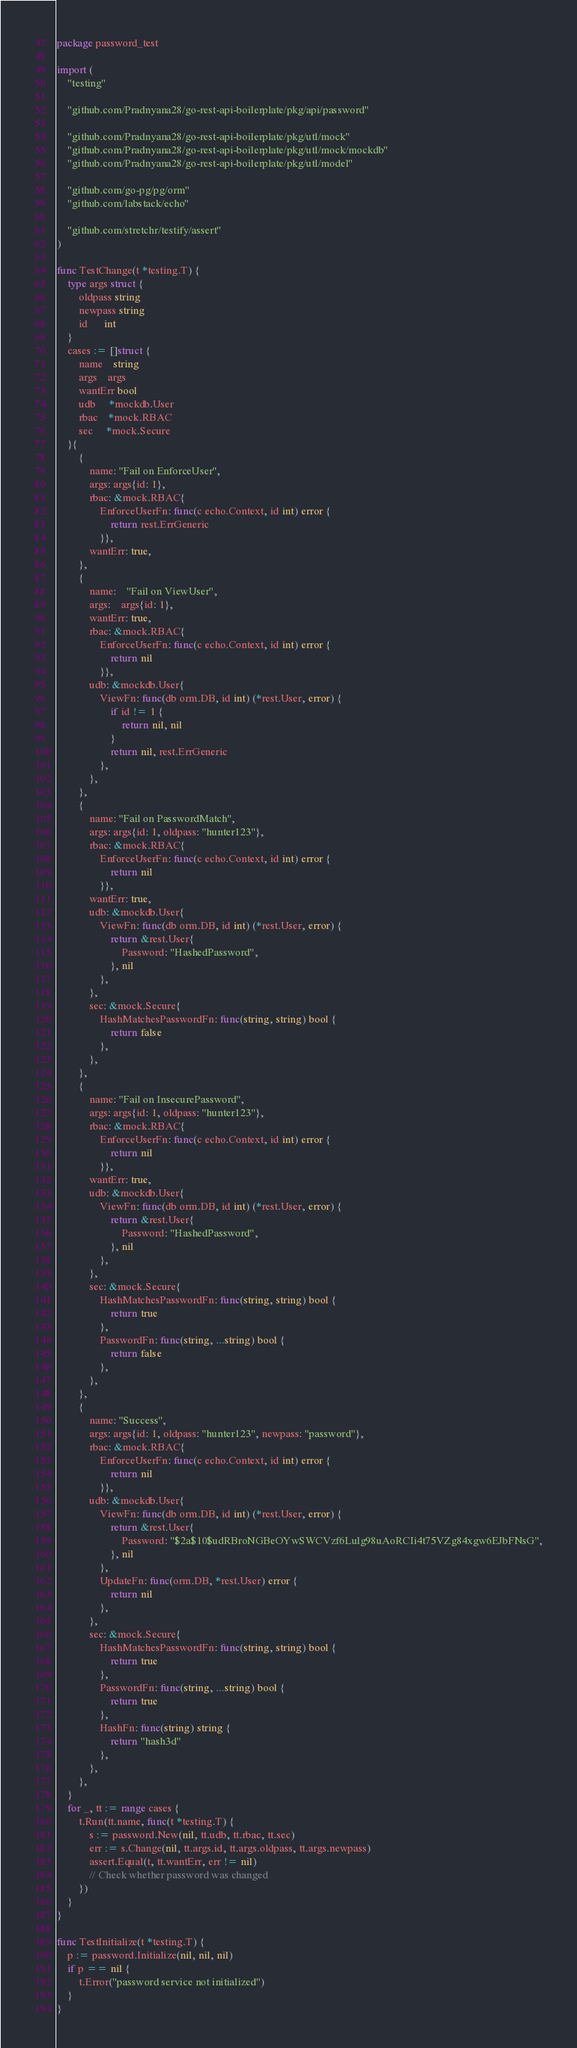Convert code to text. <code><loc_0><loc_0><loc_500><loc_500><_Go_>package password_test

import (
	"testing"

	"github.com/Pradnyana28/go-rest-api-boilerplate/pkg/api/password"

	"github.com/Pradnyana28/go-rest-api-boilerplate/pkg/utl/mock"
	"github.com/Pradnyana28/go-rest-api-boilerplate/pkg/utl/mock/mockdb"
	"github.com/Pradnyana28/go-rest-api-boilerplate/pkg/utl/model"

	"github.com/go-pg/pg/orm"
	"github.com/labstack/echo"

	"github.com/stretchr/testify/assert"
)

func TestChange(t *testing.T) {
	type args struct {
		oldpass string
		newpass string
		id      int
	}
	cases := []struct {
		name    string
		args    args
		wantErr bool
		udb     *mockdb.User
		rbac    *mock.RBAC
		sec     *mock.Secure
	}{
		{
			name: "Fail on EnforceUser",
			args: args{id: 1},
			rbac: &mock.RBAC{
				EnforceUserFn: func(c echo.Context, id int) error {
					return rest.ErrGeneric
				}},
			wantErr: true,
		},
		{
			name:    "Fail on ViewUser",
			args:    args{id: 1},
			wantErr: true,
			rbac: &mock.RBAC{
				EnforceUserFn: func(c echo.Context, id int) error {
					return nil
				}},
			udb: &mockdb.User{
				ViewFn: func(db orm.DB, id int) (*rest.User, error) {
					if id != 1 {
						return nil, nil
					}
					return nil, rest.ErrGeneric
				},
			},
		},
		{
			name: "Fail on PasswordMatch",
			args: args{id: 1, oldpass: "hunter123"},
			rbac: &mock.RBAC{
				EnforceUserFn: func(c echo.Context, id int) error {
					return nil
				}},
			wantErr: true,
			udb: &mockdb.User{
				ViewFn: func(db orm.DB, id int) (*rest.User, error) {
					return &rest.User{
						Password: "HashedPassword",
					}, nil
				},
			},
			sec: &mock.Secure{
				HashMatchesPasswordFn: func(string, string) bool {
					return false
				},
			},
		},
		{
			name: "Fail on InsecurePassword",
			args: args{id: 1, oldpass: "hunter123"},
			rbac: &mock.RBAC{
				EnforceUserFn: func(c echo.Context, id int) error {
					return nil
				}},
			wantErr: true,
			udb: &mockdb.User{
				ViewFn: func(db orm.DB, id int) (*rest.User, error) {
					return &rest.User{
						Password: "HashedPassword",
					}, nil
				},
			},
			sec: &mock.Secure{
				HashMatchesPasswordFn: func(string, string) bool {
					return true
				},
				PasswordFn: func(string, ...string) bool {
					return false
				},
			},
		},
		{
			name: "Success",
			args: args{id: 1, oldpass: "hunter123", newpass: "password"},
			rbac: &mock.RBAC{
				EnforceUserFn: func(c echo.Context, id int) error {
					return nil
				}},
			udb: &mockdb.User{
				ViewFn: func(db orm.DB, id int) (*rest.User, error) {
					return &rest.User{
						Password: "$2a$10$udRBroNGBeOYwSWCVzf6Lulg98uAoRCIi4t75VZg84xgw6EJbFNsG",
					}, nil
				},
				UpdateFn: func(orm.DB, *rest.User) error {
					return nil
				},
			},
			sec: &mock.Secure{
				HashMatchesPasswordFn: func(string, string) bool {
					return true
				},
				PasswordFn: func(string, ...string) bool {
					return true
				},
				HashFn: func(string) string {
					return "hash3d"
				},
			},
		},
	}
	for _, tt := range cases {
		t.Run(tt.name, func(t *testing.T) {
			s := password.New(nil, tt.udb, tt.rbac, tt.sec)
			err := s.Change(nil, tt.args.id, tt.args.oldpass, tt.args.newpass)
			assert.Equal(t, tt.wantErr, err != nil)
			// Check whether password was changed
		})
	}
}

func TestInitialize(t *testing.T) {
	p := password.Initialize(nil, nil, nil)
	if p == nil {
		t.Error("password service not initialized")
	}
}
</code> 